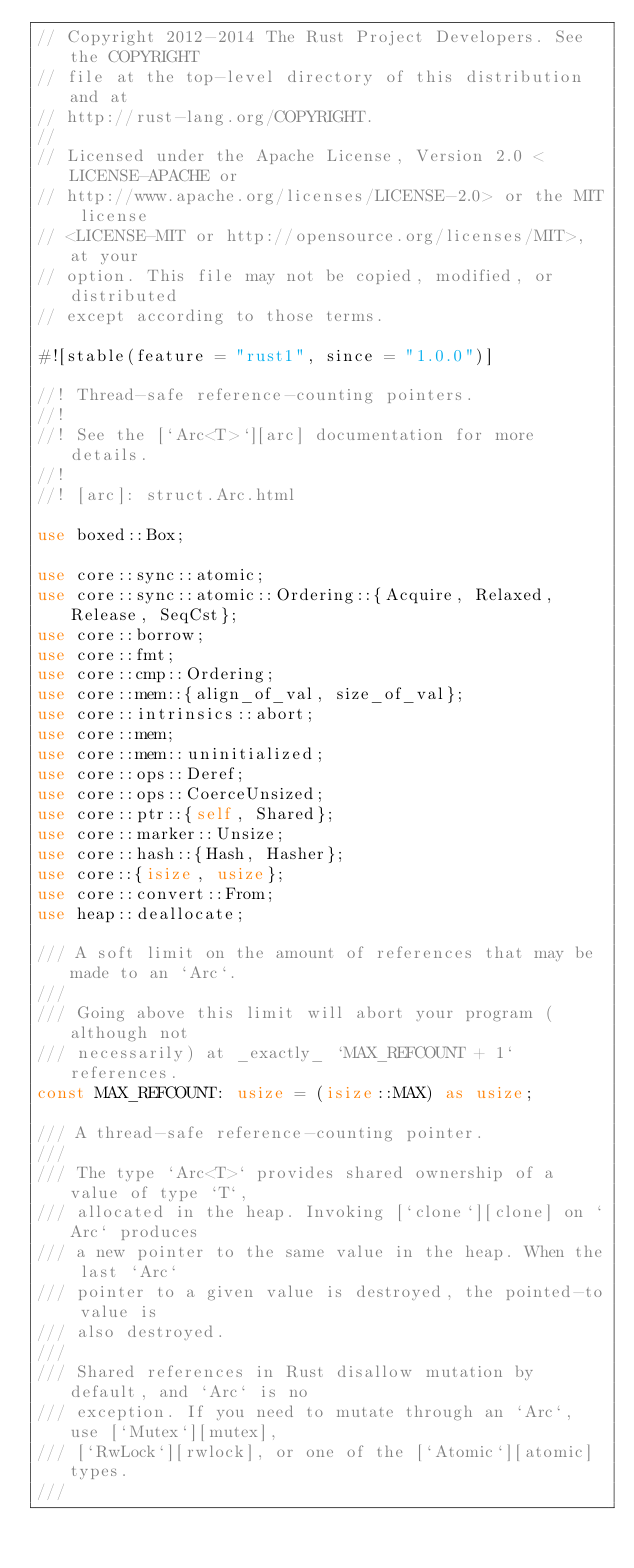<code> <loc_0><loc_0><loc_500><loc_500><_Rust_>// Copyright 2012-2014 The Rust Project Developers. See the COPYRIGHT
// file at the top-level directory of this distribution and at
// http://rust-lang.org/COPYRIGHT.
//
// Licensed under the Apache License, Version 2.0 <LICENSE-APACHE or
// http://www.apache.org/licenses/LICENSE-2.0> or the MIT license
// <LICENSE-MIT or http://opensource.org/licenses/MIT>, at your
// option. This file may not be copied, modified, or distributed
// except according to those terms.

#![stable(feature = "rust1", since = "1.0.0")]

//! Thread-safe reference-counting pointers.
//!
//! See the [`Arc<T>`][arc] documentation for more details.
//!
//! [arc]: struct.Arc.html

use boxed::Box;

use core::sync::atomic;
use core::sync::atomic::Ordering::{Acquire, Relaxed, Release, SeqCst};
use core::borrow;
use core::fmt;
use core::cmp::Ordering;
use core::mem::{align_of_val, size_of_val};
use core::intrinsics::abort;
use core::mem;
use core::mem::uninitialized;
use core::ops::Deref;
use core::ops::CoerceUnsized;
use core::ptr::{self, Shared};
use core::marker::Unsize;
use core::hash::{Hash, Hasher};
use core::{isize, usize};
use core::convert::From;
use heap::deallocate;

/// A soft limit on the amount of references that may be made to an `Arc`.
///
/// Going above this limit will abort your program (although not
/// necessarily) at _exactly_ `MAX_REFCOUNT + 1` references.
const MAX_REFCOUNT: usize = (isize::MAX) as usize;

/// A thread-safe reference-counting pointer.
///
/// The type `Arc<T>` provides shared ownership of a value of type `T`,
/// allocated in the heap. Invoking [`clone`][clone] on `Arc` produces
/// a new pointer to the same value in the heap. When the last `Arc`
/// pointer to a given value is destroyed, the pointed-to value is
/// also destroyed.
///
/// Shared references in Rust disallow mutation by default, and `Arc` is no
/// exception. If you need to mutate through an `Arc`, use [`Mutex`][mutex],
/// [`RwLock`][rwlock], or one of the [`Atomic`][atomic] types.
///</code> 